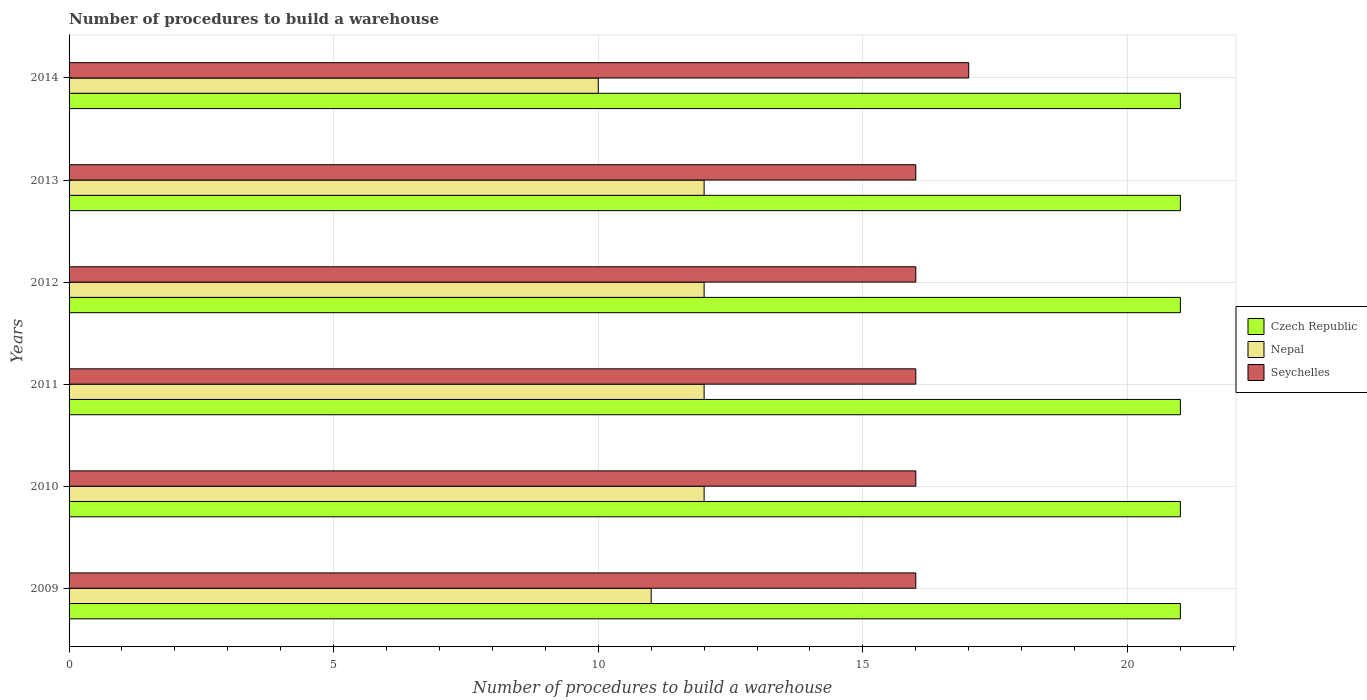How many different coloured bars are there?
Your answer should be very brief. 3. Are the number of bars per tick equal to the number of legend labels?
Keep it short and to the point. Yes. How many bars are there on the 4th tick from the top?
Your answer should be compact. 3. How many bars are there on the 5th tick from the bottom?
Keep it short and to the point. 3. In how many cases, is the number of bars for a given year not equal to the number of legend labels?
Offer a very short reply. 0. What is the number of procedures to build a warehouse in in Seychelles in 2009?
Make the answer very short. 16. Across all years, what is the maximum number of procedures to build a warehouse in in Nepal?
Give a very brief answer. 12. Across all years, what is the minimum number of procedures to build a warehouse in in Czech Republic?
Provide a short and direct response. 21. In which year was the number of procedures to build a warehouse in in Seychelles minimum?
Your response must be concise. 2009. What is the total number of procedures to build a warehouse in in Nepal in the graph?
Give a very brief answer. 69. What is the difference between the number of procedures to build a warehouse in in Nepal in 2009 and the number of procedures to build a warehouse in in Seychelles in 2013?
Your answer should be very brief. -5. In the year 2013, what is the difference between the number of procedures to build a warehouse in in Czech Republic and number of procedures to build a warehouse in in Seychelles?
Keep it short and to the point. 5. What is the ratio of the number of procedures to build a warehouse in in Nepal in 2009 to that in 2013?
Keep it short and to the point. 0.92. Is the number of procedures to build a warehouse in in Nepal in 2010 less than that in 2013?
Provide a short and direct response. No. What is the difference between the highest and the second highest number of procedures to build a warehouse in in Czech Republic?
Your response must be concise. 0. What is the difference between the highest and the lowest number of procedures to build a warehouse in in Seychelles?
Provide a succinct answer. 1. What does the 2nd bar from the top in 2014 represents?
Give a very brief answer. Nepal. What does the 1st bar from the bottom in 2009 represents?
Give a very brief answer. Czech Republic. How many bars are there?
Provide a short and direct response. 18. Where does the legend appear in the graph?
Make the answer very short. Center right. How are the legend labels stacked?
Offer a terse response. Vertical. What is the title of the graph?
Provide a short and direct response. Number of procedures to build a warehouse. Does "Latin America(all income levels)" appear as one of the legend labels in the graph?
Offer a very short reply. No. What is the label or title of the X-axis?
Make the answer very short. Number of procedures to build a warehouse. What is the Number of procedures to build a warehouse of Czech Republic in 2010?
Make the answer very short. 21. What is the Number of procedures to build a warehouse of Seychelles in 2010?
Your response must be concise. 16. What is the Number of procedures to build a warehouse of Czech Republic in 2011?
Your answer should be very brief. 21. What is the Number of procedures to build a warehouse of Nepal in 2011?
Give a very brief answer. 12. What is the Number of procedures to build a warehouse of Seychelles in 2011?
Provide a succinct answer. 16. Across all years, what is the maximum Number of procedures to build a warehouse of Czech Republic?
Provide a succinct answer. 21. Across all years, what is the maximum Number of procedures to build a warehouse of Nepal?
Keep it short and to the point. 12. Across all years, what is the minimum Number of procedures to build a warehouse of Czech Republic?
Your answer should be very brief. 21. What is the total Number of procedures to build a warehouse of Czech Republic in the graph?
Provide a succinct answer. 126. What is the total Number of procedures to build a warehouse of Nepal in the graph?
Provide a succinct answer. 69. What is the total Number of procedures to build a warehouse of Seychelles in the graph?
Keep it short and to the point. 97. What is the difference between the Number of procedures to build a warehouse in Czech Republic in 2009 and that in 2010?
Provide a short and direct response. 0. What is the difference between the Number of procedures to build a warehouse of Seychelles in 2009 and that in 2010?
Provide a short and direct response. 0. What is the difference between the Number of procedures to build a warehouse in Czech Republic in 2009 and that in 2011?
Keep it short and to the point. 0. What is the difference between the Number of procedures to build a warehouse of Seychelles in 2009 and that in 2011?
Your answer should be compact. 0. What is the difference between the Number of procedures to build a warehouse of Nepal in 2009 and that in 2012?
Keep it short and to the point. -1. What is the difference between the Number of procedures to build a warehouse in Seychelles in 2009 and that in 2012?
Offer a terse response. 0. What is the difference between the Number of procedures to build a warehouse of Czech Republic in 2009 and that in 2013?
Make the answer very short. 0. What is the difference between the Number of procedures to build a warehouse in Nepal in 2009 and that in 2013?
Your response must be concise. -1. What is the difference between the Number of procedures to build a warehouse of Seychelles in 2009 and that in 2013?
Your response must be concise. 0. What is the difference between the Number of procedures to build a warehouse of Nepal in 2009 and that in 2014?
Offer a very short reply. 1. What is the difference between the Number of procedures to build a warehouse of Seychelles in 2009 and that in 2014?
Ensure brevity in your answer.  -1. What is the difference between the Number of procedures to build a warehouse of Nepal in 2010 and that in 2011?
Your answer should be very brief. 0. What is the difference between the Number of procedures to build a warehouse in Seychelles in 2010 and that in 2012?
Offer a very short reply. 0. What is the difference between the Number of procedures to build a warehouse of Nepal in 2010 and that in 2013?
Your response must be concise. 0. What is the difference between the Number of procedures to build a warehouse of Seychelles in 2010 and that in 2013?
Give a very brief answer. 0. What is the difference between the Number of procedures to build a warehouse of Seychelles in 2010 and that in 2014?
Give a very brief answer. -1. What is the difference between the Number of procedures to build a warehouse of Czech Republic in 2011 and that in 2013?
Ensure brevity in your answer.  0. What is the difference between the Number of procedures to build a warehouse in Seychelles in 2011 and that in 2013?
Your answer should be compact. 0. What is the difference between the Number of procedures to build a warehouse of Czech Republic in 2011 and that in 2014?
Ensure brevity in your answer.  0. What is the difference between the Number of procedures to build a warehouse of Nepal in 2011 and that in 2014?
Keep it short and to the point. 2. What is the difference between the Number of procedures to build a warehouse in Seychelles in 2011 and that in 2014?
Give a very brief answer. -1. What is the difference between the Number of procedures to build a warehouse in Czech Republic in 2012 and that in 2013?
Your answer should be compact. 0. What is the difference between the Number of procedures to build a warehouse in Nepal in 2012 and that in 2013?
Make the answer very short. 0. What is the difference between the Number of procedures to build a warehouse in Czech Republic in 2012 and that in 2014?
Your answer should be compact. 0. What is the difference between the Number of procedures to build a warehouse in Nepal in 2012 and that in 2014?
Ensure brevity in your answer.  2. What is the difference between the Number of procedures to build a warehouse in Seychelles in 2012 and that in 2014?
Provide a succinct answer. -1. What is the difference between the Number of procedures to build a warehouse in Nepal in 2013 and that in 2014?
Offer a very short reply. 2. What is the difference between the Number of procedures to build a warehouse of Seychelles in 2013 and that in 2014?
Offer a terse response. -1. What is the difference between the Number of procedures to build a warehouse in Czech Republic in 2009 and the Number of procedures to build a warehouse in Nepal in 2010?
Keep it short and to the point. 9. What is the difference between the Number of procedures to build a warehouse of Czech Republic in 2009 and the Number of procedures to build a warehouse of Seychelles in 2011?
Your answer should be very brief. 5. What is the difference between the Number of procedures to build a warehouse in Czech Republic in 2009 and the Number of procedures to build a warehouse in Nepal in 2013?
Your answer should be compact. 9. What is the difference between the Number of procedures to build a warehouse in Czech Republic in 2009 and the Number of procedures to build a warehouse in Seychelles in 2013?
Make the answer very short. 5. What is the difference between the Number of procedures to build a warehouse in Czech Republic in 2009 and the Number of procedures to build a warehouse in Nepal in 2014?
Make the answer very short. 11. What is the difference between the Number of procedures to build a warehouse in Czech Republic in 2009 and the Number of procedures to build a warehouse in Seychelles in 2014?
Your answer should be compact. 4. What is the difference between the Number of procedures to build a warehouse in Nepal in 2009 and the Number of procedures to build a warehouse in Seychelles in 2014?
Offer a terse response. -6. What is the difference between the Number of procedures to build a warehouse of Czech Republic in 2010 and the Number of procedures to build a warehouse of Nepal in 2011?
Your answer should be compact. 9. What is the difference between the Number of procedures to build a warehouse of Czech Republic in 2010 and the Number of procedures to build a warehouse of Seychelles in 2011?
Provide a short and direct response. 5. What is the difference between the Number of procedures to build a warehouse in Nepal in 2010 and the Number of procedures to build a warehouse in Seychelles in 2011?
Keep it short and to the point. -4. What is the difference between the Number of procedures to build a warehouse of Nepal in 2010 and the Number of procedures to build a warehouse of Seychelles in 2012?
Provide a succinct answer. -4. What is the difference between the Number of procedures to build a warehouse of Czech Republic in 2010 and the Number of procedures to build a warehouse of Seychelles in 2013?
Give a very brief answer. 5. What is the difference between the Number of procedures to build a warehouse in Nepal in 2010 and the Number of procedures to build a warehouse in Seychelles in 2013?
Give a very brief answer. -4. What is the difference between the Number of procedures to build a warehouse of Czech Republic in 2010 and the Number of procedures to build a warehouse of Seychelles in 2014?
Your answer should be compact. 4. What is the difference between the Number of procedures to build a warehouse in Czech Republic in 2011 and the Number of procedures to build a warehouse in Nepal in 2012?
Keep it short and to the point. 9. What is the difference between the Number of procedures to build a warehouse in Czech Republic in 2011 and the Number of procedures to build a warehouse in Seychelles in 2012?
Keep it short and to the point. 5. What is the difference between the Number of procedures to build a warehouse in Nepal in 2011 and the Number of procedures to build a warehouse in Seychelles in 2012?
Provide a succinct answer. -4. What is the difference between the Number of procedures to build a warehouse in Czech Republic in 2011 and the Number of procedures to build a warehouse in Nepal in 2013?
Offer a terse response. 9. What is the difference between the Number of procedures to build a warehouse in Nepal in 2011 and the Number of procedures to build a warehouse in Seychelles in 2013?
Give a very brief answer. -4. What is the difference between the Number of procedures to build a warehouse of Czech Republic in 2011 and the Number of procedures to build a warehouse of Nepal in 2014?
Provide a succinct answer. 11. What is the difference between the Number of procedures to build a warehouse of Czech Republic in 2011 and the Number of procedures to build a warehouse of Seychelles in 2014?
Provide a succinct answer. 4. What is the difference between the Number of procedures to build a warehouse in Czech Republic in 2012 and the Number of procedures to build a warehouse in Seychelles in 2013?
Your answer should be very brief. 5. What is the difference between the Number of procedures to build a warehouse of Nepal in 2012 and the Number of procedures to build a warehouse of Seychelles in 2014?
Offer a very short reply. -5. What is the difference between the Number of procedures to build a warehouse of Czech Republic in 2013 and the Number of procedures to build a warehouse of Nepal in 2014?
Keep it short and to the point. 11. What is the difference between the Number of procedures to build a warehouse in Czech Republic in 2013 and the Number of procedures to build a warehouse in Seychelles in 2014?
Your answer should be very brief. 4. What is the average Number of procedures to build a warehouse in Czech Republic per year?
Your response must be concise. 21. What is the average Number of procedures to build a warehouse of Nepal per year?
Give a very brief answer. 11.5. What is the average Number of procedures to build a warehouse in Seychelles per year?
Your answer should be very brief. 16.17. In the year 2009, what is the difference between the Number of procedures to build a warehouse of Czech Republic and Number of procedures to build a warehouse of Nepal?
Your answer should be very brief. 10. In the year 2010, what is the difference between the Number of procedures to build a warehouse in Czech Republic and Number of procedures to build a warehouse in Nepal?
Your answer should be compact. 9. In the year 2010, what is the difference between the Number of procedures to build a warehouse in Czech Republic and Number of procedures to build a warehouse in Seychelles?
Make the answer very short. 5. In the year 2011, what is the difference between the Number of procedures to build a warehouse of Czech Republic and Number of procedures to build a warehouse of Nepal?
Your answer should be compact. 9. In the year 2011, what is the difference between the Number of procedures to build a warehouse of Nepal and Number of procedures to build a warehouse of Seychelles?
Provide a succinct answer. -4. In the year 2013, what is the difference between the Number of procedures to build a warehouse of Czech Republic and Number of procedures to build a warehouse of Seychelles?
Make the answer very short. 5. What is the ratio of the Number of procedures to build a warehouse in Nepal in 2009 to that in 2010?
Keep it short and to the point. 0.92. What is the ratio of the Number of procedures to build a warehouse of Seychelles in 2009 to that in 2010?
Give a very brief answer. 1. What is the ratio of the Number of procedures to build a warehouse in Nepal in 2009 to that in 2011?
Offer a terse response. 0.92. What is the ratio of the Number of procedures to build a warehouse in Czech Republic in 2009 to that in 2012?
Provide a short and direct response. 1. What is the ratio of the Number of procedures to build a warehouse of Seychelles in 2009 to that in 2012?
Provide a short and direct response. 1. What is the ratio of the Number of procedures to build a warehouse in Czech Republic in 2009 to that in 2013?
Your response must be concise. 1. What is the ratio of the Number of procedures to build a warehouse in Nepal in 2009 to that in 2013?
Provide a succinct answer. 0.92. What is the ratio of the Number of procedures to build a warehouse of Seychelles in 2009 to that in 2013?
Make the answer very short. 1. What is the ratio of the Number of procedures to build a warehouse of Seychelles in 2009 to that in 2014?
Provide a succinct answer. 0.94. What is the ratio of the Number of procedures to build a warehouse of Czech Republic in 2010 to that in 2011?
Ensure brevity in your answer.  1. What is the ratio of the Number of procedures to build a warehouse of Czech Republic in 2010 to that in 2013?
Offer a terse response. 1. What is the ratio of the Number of procedures to build a warehouse of Nepal in 2010 to that in 2013?
Provide a short and direct response. 1. What is the ratio of the Number of procedures to build a warehouse of Seychelles in 2010 to that in 2013?
Your answer should be very brief. 1. What is the ratio of the Number of procedures to build a warehouse of Czech Republic in 2010 to that in 2014?
Keep it short and to the point. 1. What is the ratio of the Number of procedures to build a warehouse of Czech Republic in 2011 to that in 2012?
Provide a succinct answer. 1. What is the ratio of the Number of procedures to build a warehouse of Nepal in 2011 to that in 2012?
Ensure brevity in your answer.  1. What is the ratio of the Number of procedures to build a warehouse in Seychelles in 2011 to that in 2012?
Provide a short and direct response. 1. What is the ratio of the Number of procedures to build a warehouse of Czech Republic in 2011 to that in 2013?
Provide a short and direct response. 1. What is the ratio of the Number of procedures to build a warehouse in Nepal in 2011 to that in 2014?
Give a very brief answer. 1.2. What is the ratio of the Number of procedures to build a warehouse of Czech Republic in 2012 to that in 2013?
Offer a very short reply. 1. What is the ratio of the Number of procedures to build a warehouse in Nepal in 2012 to that in 2014?
Your response must be concise. 1.2. What is the ratio of the Number of procedures to build a warehouse of Czech Republic in 2013 to that in 2014?
Offer a terse response. 1. What is the ratio of the Number of procedures to build a warehouse of Seychelles in 2013 to that in 2014?
Give a very brief answer. 0.94. What is the difference between the highest and the second highest Number of procedures to build a warehouse in Nepal?
Give a very brief answer. 0. What is the difference between the highest and the lowest Number of procedures to build a warehouse of Seychelles?
Your answer should be compact. 1. 